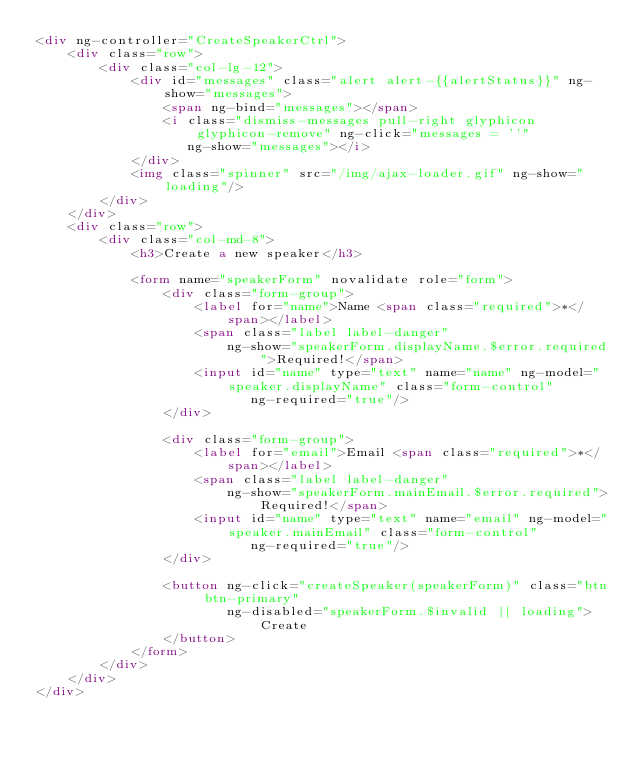Convert code to text. <code><loc_0><loc_0><loc_500><loc_500><_HTML_><div ng-controller="CreateSpeakerCtrl">
    <div class="row">
        <div class="col-lg-12">
            <div id="messages" class="alert alert-{{alertStatus}}" ng-show="messages">
                <span ng-bind="messages"></span>
                <i class="dismiss-messages pull-right glyphicon glyphicon-remove" ng-click="messages = ''"
                   ng-show="messages"></i>
            </div>
            <img class="spinner" src="/img/ajax-loader.gif" ng-show="loading"/>
        </div>
    </div>
    <div class="row">
        <div class="col-md-8">
            <h3>Create a new speaker</h3>

            <form name="speakerForm" novalidate role="form">
                <div class="form-group">
                    <label for="name">Name <span class="required">*</span></label>
                    <span class="label label-danger"
                        ng-show="speakerForm.displayName.$error.required">Required!</span>
                    <input id="name" type="text" name="name" ng-model="speaker.displayName" class="form-control"
                           ng-required="true"/>
                </div>

                <div class="form-group">
                    <label for="email">Email <span class="required">*</span></label>
                    <span class="label label-danger"
                        ng-show="speakerForm.mainEmail.$error.required">Required!</span>
                    <input id="name" type="text" name="email" ng-model="speaker.mainEmail" class="form-control"
                           ng-required="true"/>
                </div>

                <button ng-click="createSpeaker(speakerForm)" class="btn btn-primary"
                        ng-disabled="speakerForm.$invalid || loading">Create
                </button>
            </form>
        </div>
    </div>
</div></code> 